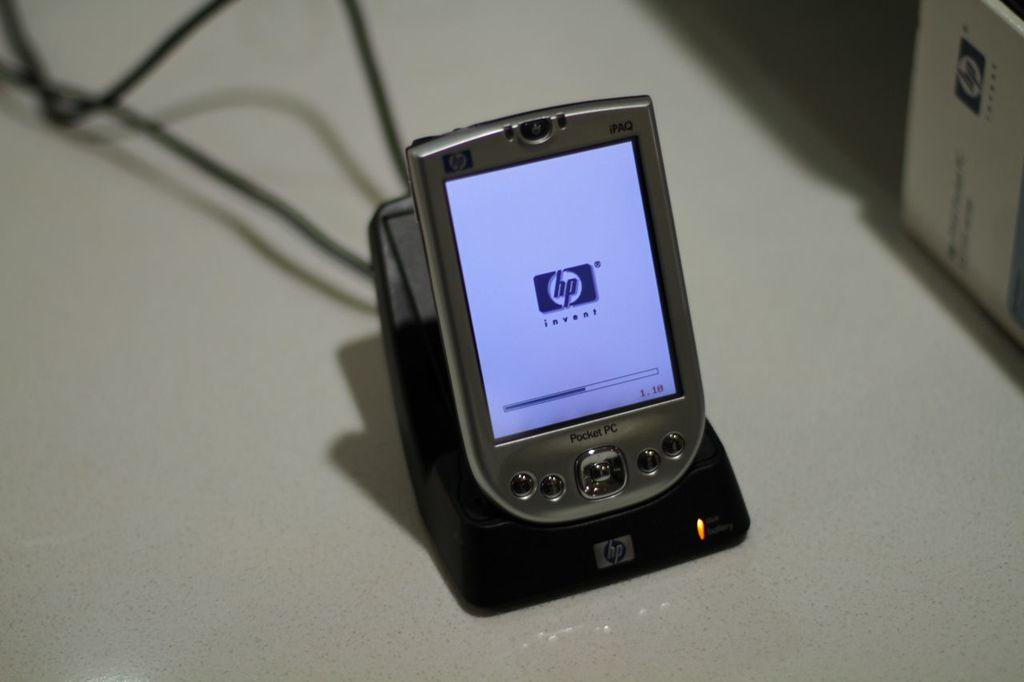Provide a one-sentence caption for the provided image. A HP Pocket PC on an HP charging dock. 